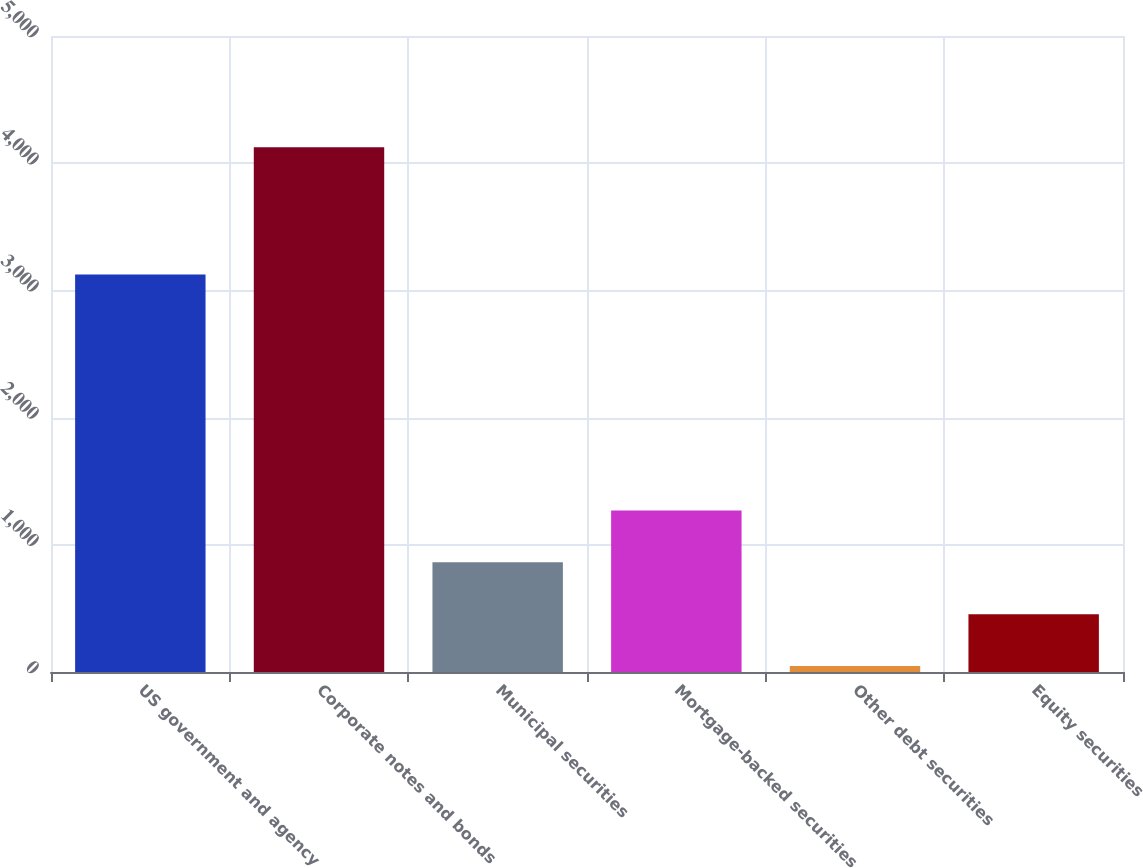Convert chart. <chart><loc_0><loc_0><loc_500><loc_500><bar_chart><fcel>US government and agency<fcel>Corporate notes and bonds<fcel>Municipal securities<fcel>Mortgage-backed securities<fcel>Other debt securities<fcel>Equity securities<nl><fcel>3125.8<fcel>4124.7<fcel>862.3<fcel>1270.1<fcel>46.7<fcel>454.5<nl></chart> 